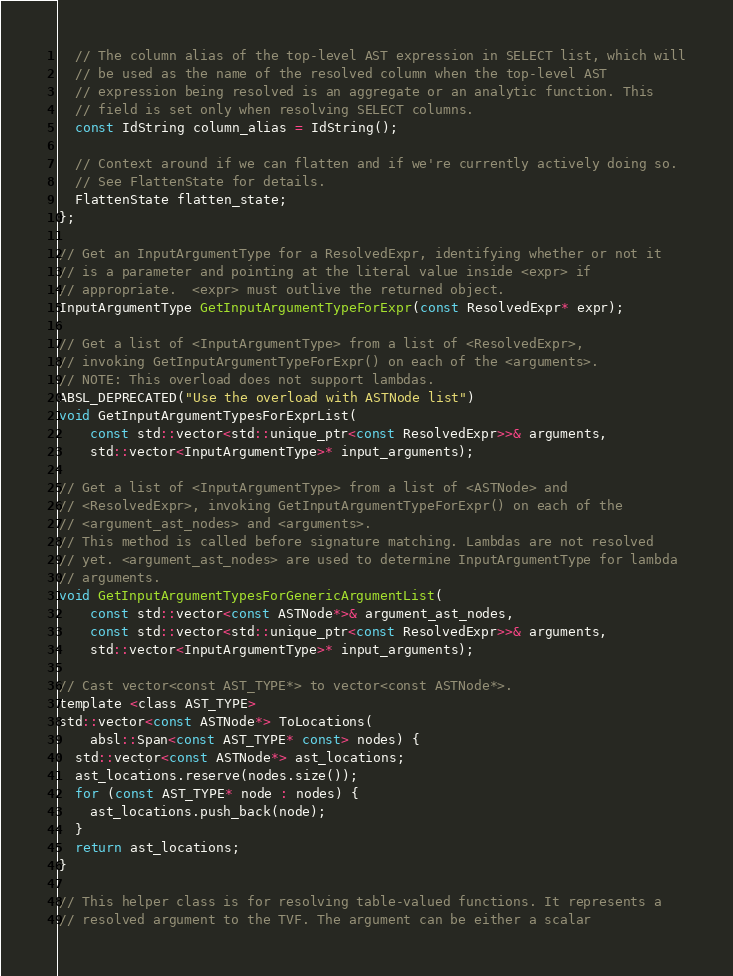<code> <loc_0><loc_0><loc_500><loc_500><_C_>  // The column alias of the top-level AST expression in SELECT list, which will
  // be used as the name of the resolved column when the top-level AST
  // expression being resolved is an aggregate or an analytic function. This
  // field is set only when resolving SELECT columns.
  const IdString column_alias = IdString();

  // Context around if we can flatten and if we're currently actively doing so.
  // See FlattenState for details.
  FlattenState flatten_state;
};

// Get an InputArgumentType for a ResolvedExpr, identifying whether or not it
// is a parameter and pointing at the literal value inside <expr> if
// appropriate.  <expr> must outlive the returned object.
InputArgumentType GetInputArgumentTypeForExpr(const ResolvedExpr* expr);

// Get a list of <InputArgumentType> from a list of <ResolvedExpr>,
// invoking GetInputArgumentTypeForExpr() on each of the <arguments>.
// NOTE: This overload does not support lambdas.
ABSL_DEPRECATED("Use the overload with ASTNode list")
void GetInputArgumentTypesForExprList(
    const std::vector<std::unique_ptr<const ResolvedExpr>>& arguments,
    std::vector<InputArgumentType>* input_arguments);

// Get a list of <InputArgumentType> from a list of <ASTNode> and
// <ResolvedExpr>, invoking GetInputArgumentTypeForExpr() on each of the
// <argument_ast_nodes> and <arguments>.
// This method is called before signature matching. Lambdas are not resolved
// yet. <argument_ast_nodes> are used to determine InputArgumentType for lambda
// arguments.
void GetInputArgumentTypesForGenericArgumentList(
    const std::vector<const ASTNode*>& argument_ast_nodes,
    const std::vector<std::unique_ptr<const ResolvedExpr>>& arguments,
    std::vector<InputArgumentType>* input_arguments);

// Cast vector<const AST_TYPE*> to vector<const ASTNode*>.
template <class AST_TYPE>
std::vector<const ASTNode*> ToLocations(
    absl::Span<const AST_TYPE* const> nodes) {
  std::vector<const ASTNode*> ast_locations;
  ast_locations.reserve(nodes.size());
  for (const AST_TYPE* node : nodes) {
    ast_locations.push_back(node);
  }
  return ast_locations;
}

// This helper class is for resolving table-valued functions. It represents a
// resolved argument to the TVF. The argument can be either a scalar</code> 